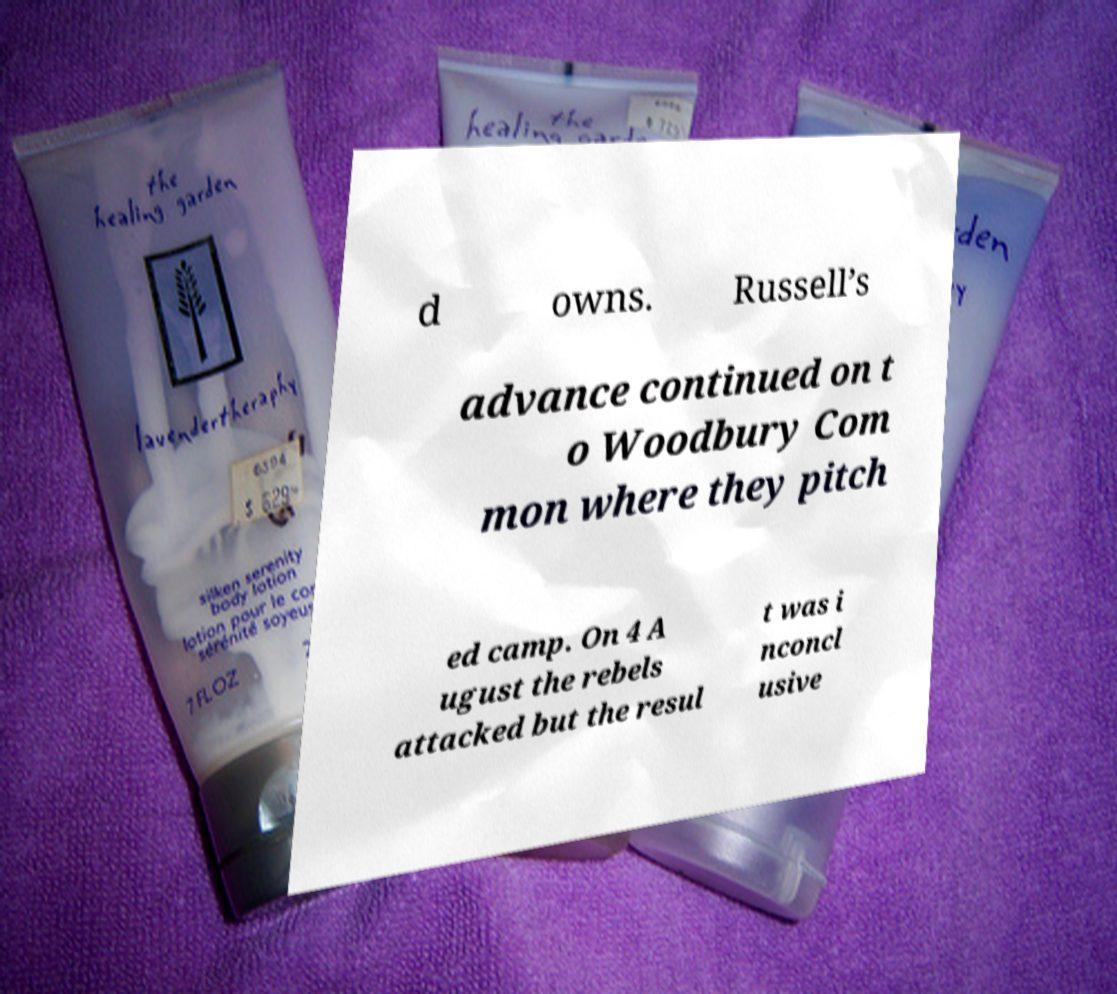For documentation purposes, I need the text within this image transcribed. Could you provide that? d owns. Russell’s advance continued on t o Woodbury Com mon where they pitch ed camp. On 4 A ugust the rebels attacked but the resul t was i nconcl usive 